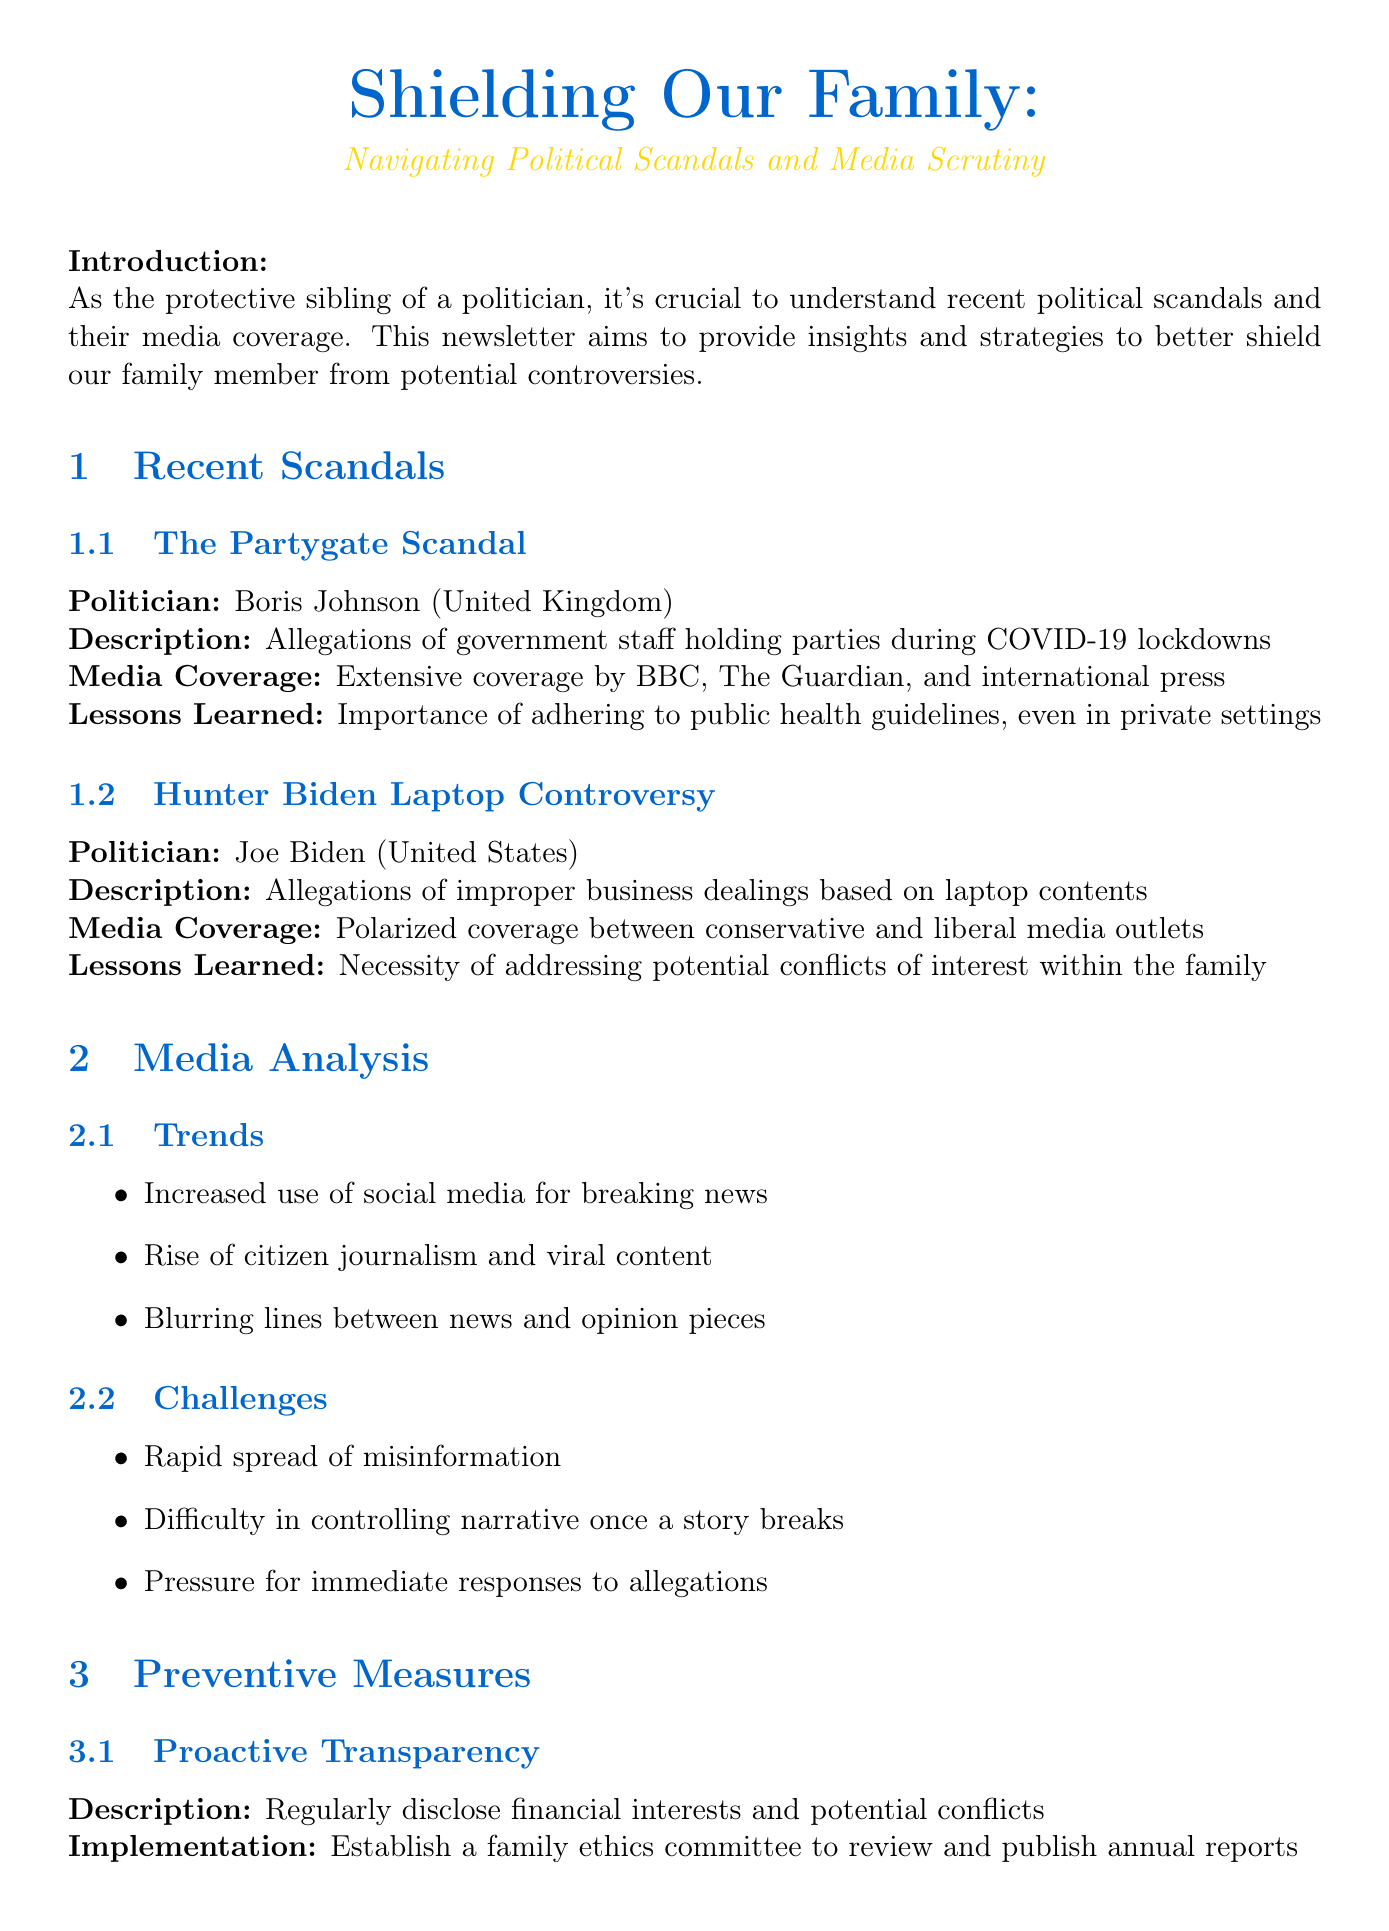what is the title of the newsletter? The title is specified at the beginning of the document, capturing the essence of its content.
Answer: Shielding Our Family: Navigating Political Scandals and Media Scrutiny who was involved in the Partygate Scandal? The document names the politician associated with the scandal.
Answer: Boris Johnson what was a key lesson learned from the Hunter Biden Laptop Controversy? The lesson focuses on potential personal issues relating to the investigation.
Answer: Necessity of addressing potential conflicts of interest within the family what media outlet provided extensive coverage of the Partygate Scandal? This is identified through the analysis of the media's role in the scandal coverage.
Answer: BBC how many preventive measures are mentioned in the newsletter? The total number of strategies discussed for safeguarding the politician is noted.
Answer: Three what is one action item proposed for family support? This particular item focuses on family dynamics and communication.
Answer: Schedule weekly family check-ins to discuss potential issues what is a trend identified in media analysis? This trend illustrates the evolving landscape of news reporting.
Answer: Increased use of social media for breaking news what is the purpose of the newsletter? The main goal is included in the introduction section of the document.
Answer: Provide insights and strategies to better shield our family member from potential controversies 